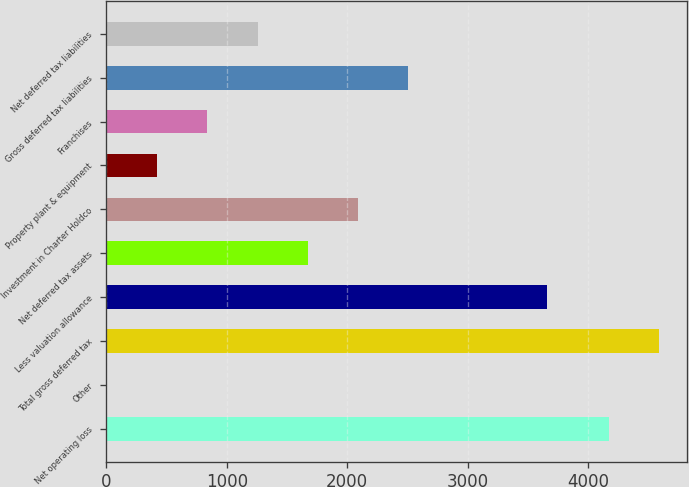<chart> <loc_0><loc_0><loc_500><loc_500><bar_chart><fcel>Net operating loss<fcel>Other<fcel>Total gross deferred tax<fcel>Less valuation allowance<fcel>Net deferred tax assets<fcel>Investment in Charter Holdco<fcel>Property plant & equipment<fcel>Franchises<fcel>Gross deferred tax liabilities<fcel>Net deferred tax liabilities<nl><fcel>4169<fcel>6<fcel>4585.9<fcel>3656<fcel>1673.6<fcel>2090.5<fcel>422.9<fcel>839.8<fcel>2507.4<fcel>1256.7<nl></chart> 